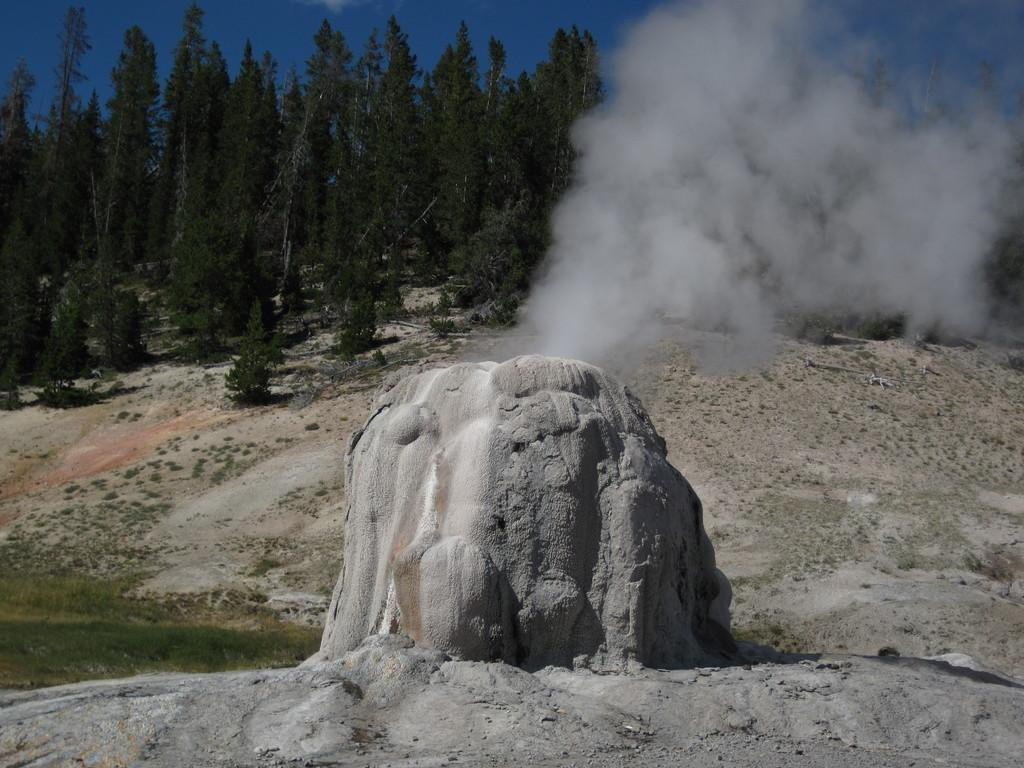What is the main subject of the image? There is a rock in the image. What can be seen in the background of the image? There are trees and the sky visible in the background of the image. What type of vase can be seen in the middle of the image? There is no vase present in the image; it features a rock and a background with trees and the sky. What kind of beef is being prepared in the image? There is no beef or any food preparation visible in the image. 